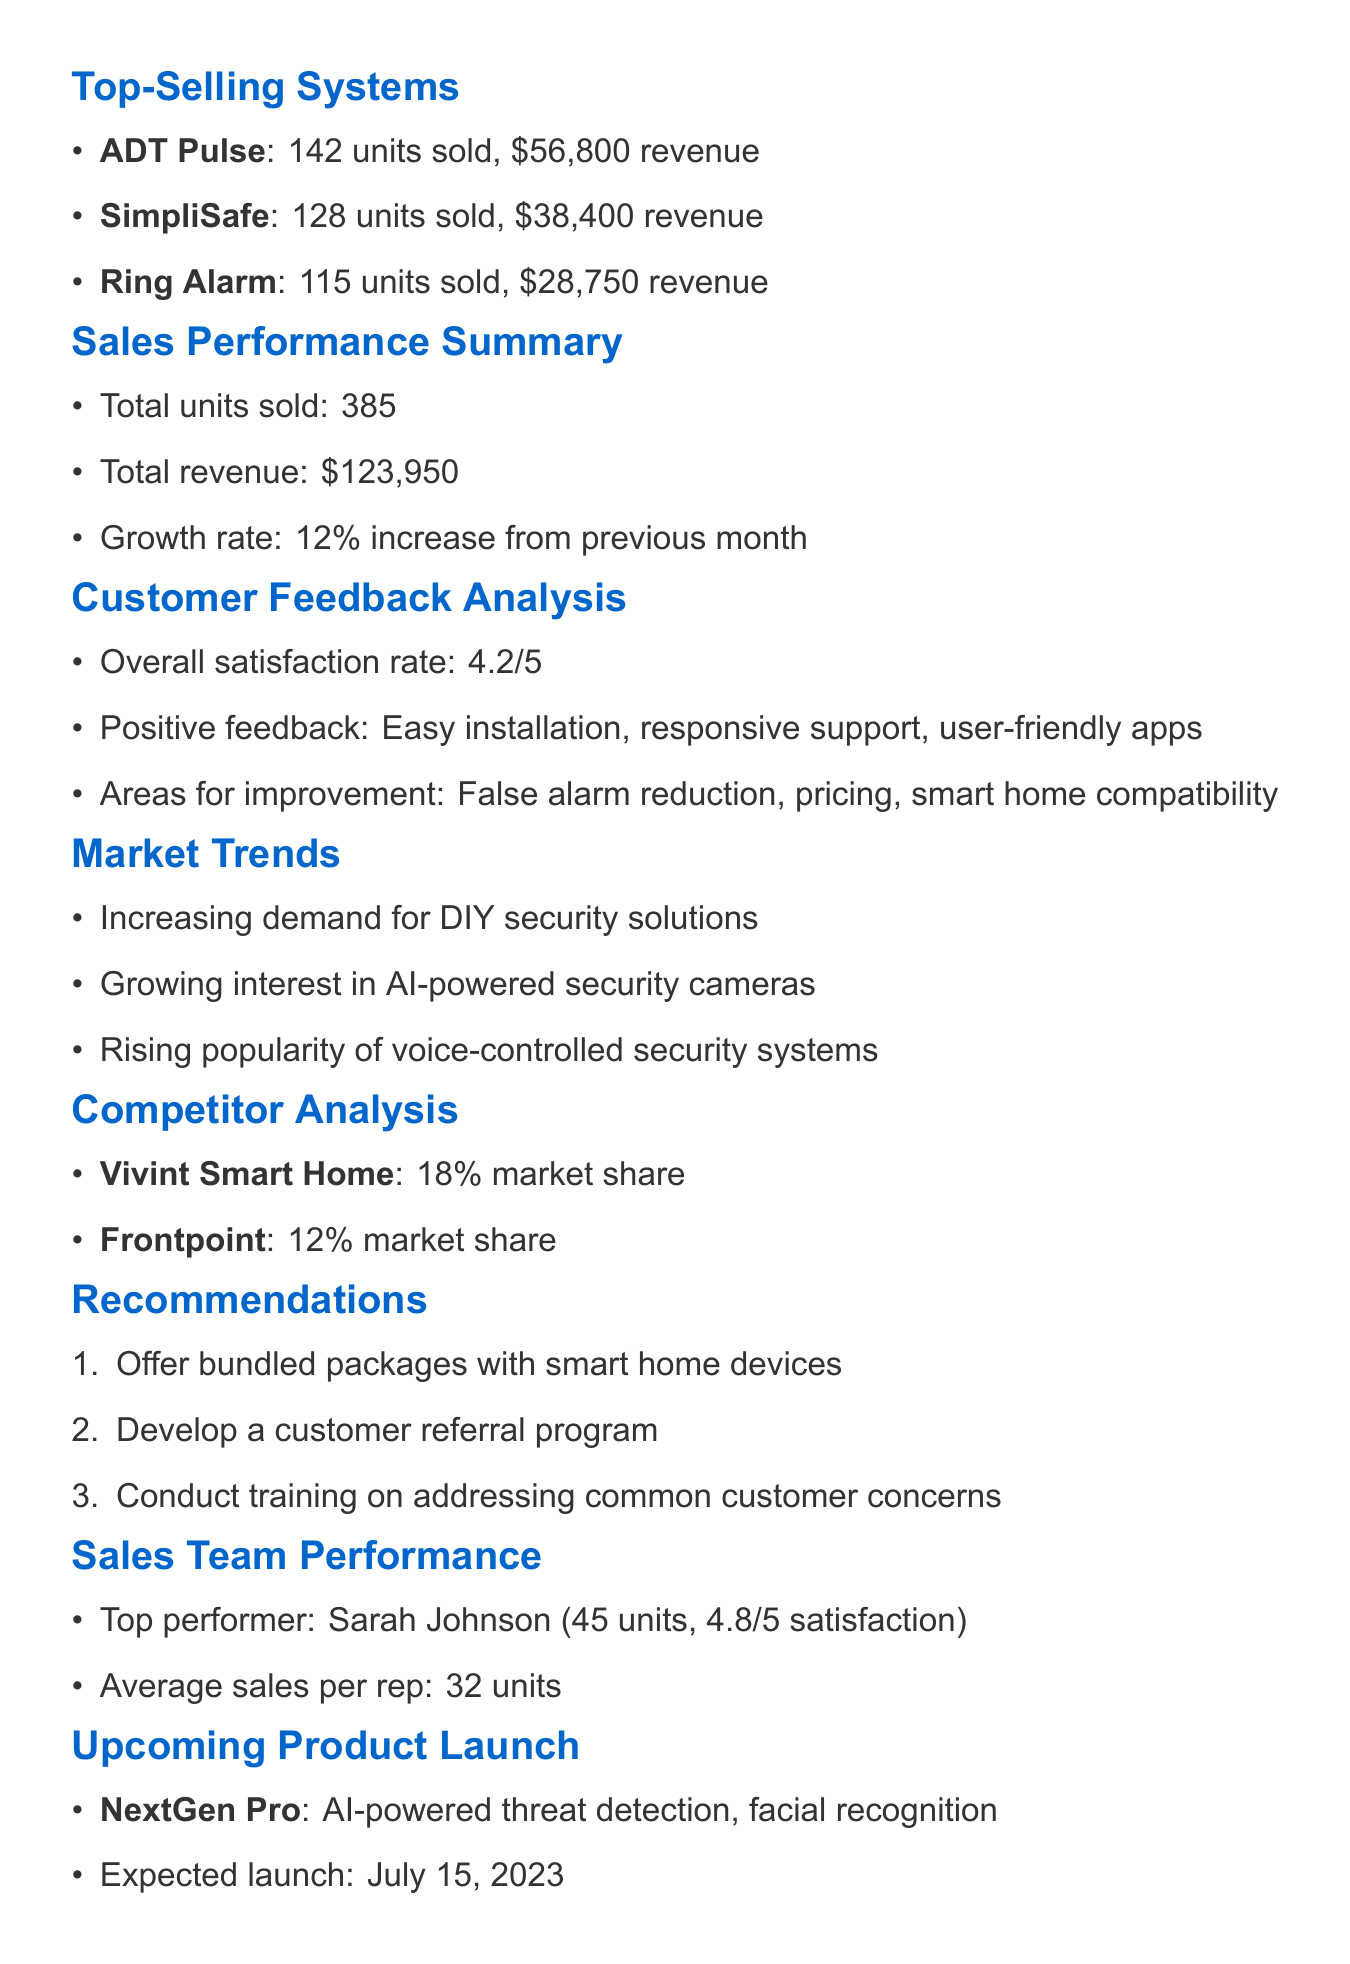what is the date of the report? The report is dated May 1, 2023, as stated at the top of the document.
Answer: May 1, 2023 how many units of ADT Pulse were sold? The document lists that 142 units of ADT Pulse were sold.
Answer: 142 what is the revenue from SimpliSafe sales? The revenue from SimpliSafe is provided in the report as $38,400.
Answer: $38,400 what is the overall satisfaction rate? The overall satisfaction rate is presented in the customer feedback section as 4.2 out of 5.
Answer: 4.2/5 who is the top performer in the sales team? The document specifies that Sarah Johnson is the top performer with 45 units sold.
Answer: Sarah Johnson what key feature is associated with Ring Alarm? The document mentions affordable pricing as one of the key features of Ring Alarm.
Answer: Affordable pricing what percentage increase in growth rate is reported? The growth rate stated is a 12% increase from the previous month, as indicated in the summary.
Answer: 12% what is a recommended action to incentivize existing customers? The recommendations section suggests developing a referral program to incentivize existing customers.
Answer: Develop a referral program what is the expected launch date for the NextGen Pro? The document notes that the expected launch date for NextGen Pro is July 15, 2023.
Answer: July 15, 2023 